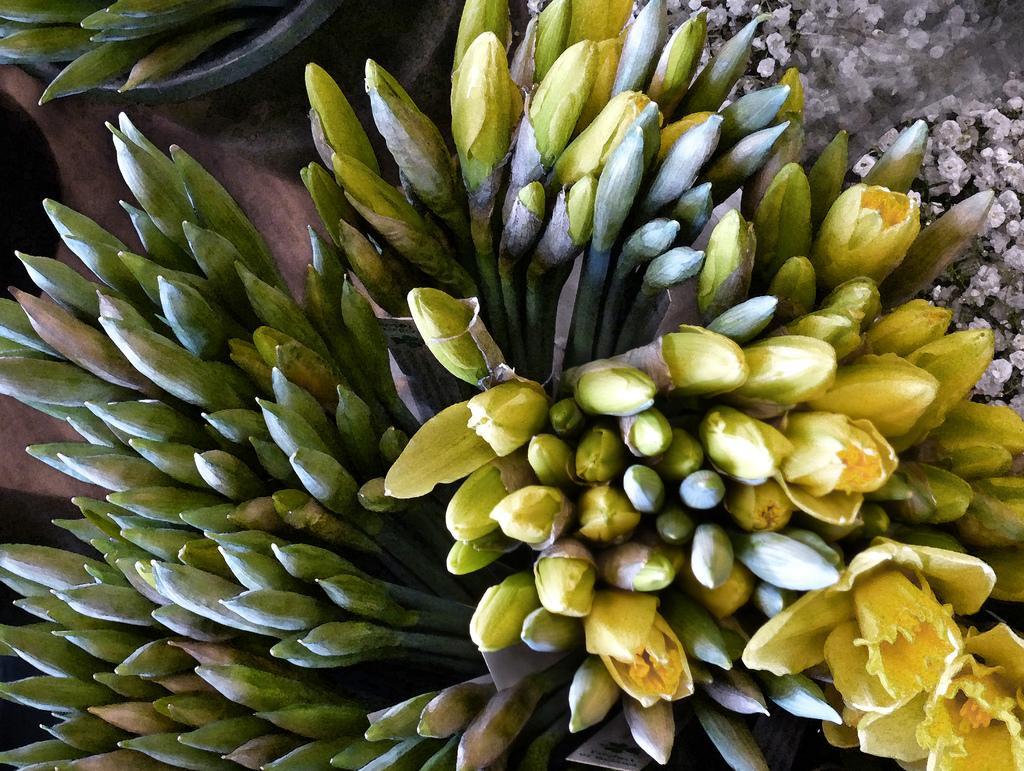Please provide a concise description of this image. In this image, there are some buds. There is a flower in the bottom right of the image. 